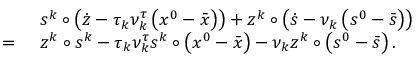Convert formula to latex. <formula><loc_0><loc_0><loc_500><loc_500>\begin{array} { r l } & { \ s ^ { k } \circ \left ( \dot { z } - \tau _ { k } \nu _ { k } ^ { \tau } \left ( { x } ^ { 0 } - \bar { x } \right ) \right ) + z ^ { k } \circ \left ( \dot { s } - \nu _ { k } \left ( s ^ { 0 } - \bar { s } \right ) \right ) } \\ { = } & { \ z ^ { k } \circ s ^ { k } - \tau _ { k } \nu _ { k } ^ { \tau } s ^ { k } \circ \left ( { x } ^ { 0 } - \bar { x } \right ) - \nu _ { k } z ^ { k } \circ \left ( { s } ^ { 0 } - \bar { s } \right ) . } \end{array}</formula> 